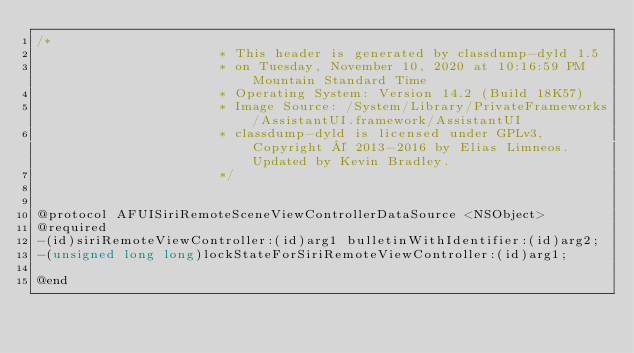<code> <loc_0><loc_0><loc_500><loc_500><_C_>/*
                       * This header is generated by classdump-dyld 1.5
                       * on Tuesday, November 10, 2020 at 10:16:59 PM Mountain Standard Time
                       * Operating System: Version 14.2 (Build 18K57)
                       * Image Source: /System/Library/PrivateFrameworks/AssistantUI.framework/AssistantUI
                       * classdump-dyld is licensed under GPLv3, Copyright © 2013-2016 by Elias Limneos. Updated by Kevin Bradley.
                       */


@protocol AFUISiriRemoteSceneViewControllerDataSource <NSObject>
@required
-(id)siriRemoteViewController:(id)arg1 bulletinWithIdentifier:(id)arg2;
-(unsigned long long)lockStateForSiriRemoteViewController:(id)arg1;

@end

</code> 